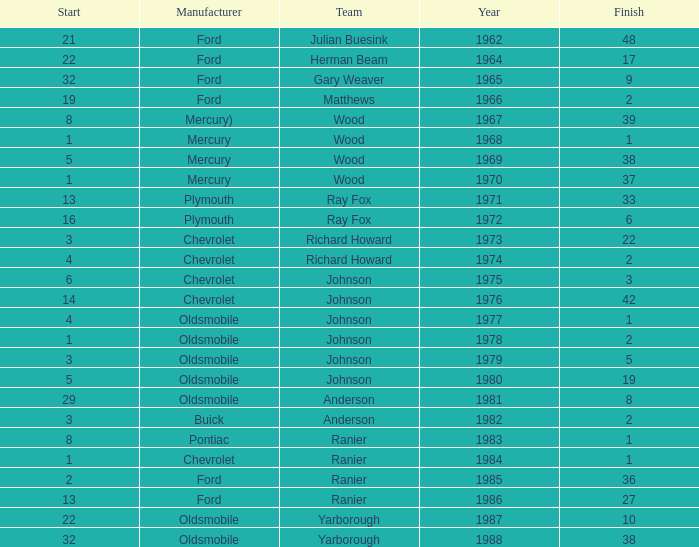Who was the maufacturer of the vehicle during the race where Cale Yarborough started at 19 and finished earlier than 42? Ford. 